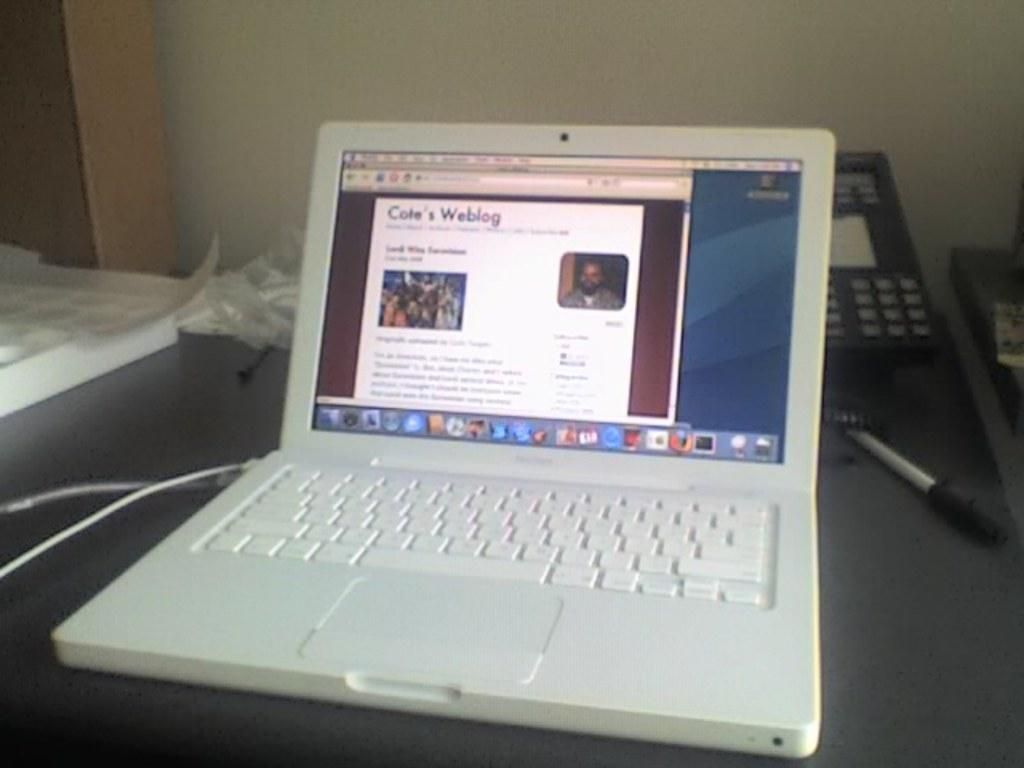What piece of furniture is visible in the image? There is a table in the image. What electronic device is on the table? A laptop is present on the table. What communication device is also on the table? A telephone is on the table. What other objects can be seen on the table? There are other objects on the table. What can be seen in the background of the image? There is a wall in the background of the image. Can you see a quiver hanging on the wall in the image? There is no quiver present in the image; only a table and a wall are visible. 